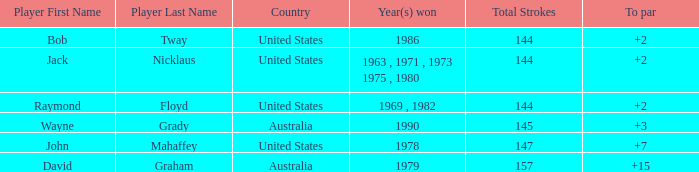How many strokes off par was the winner in 1978? 7.0. 